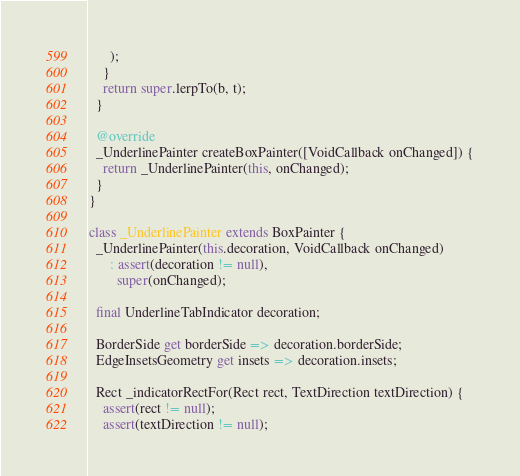Convert code to text. <code><loc_0><loc_0><loc_500><loc_500><_Dart_>      );
    }
    return super.lerpTo(b, t);
  }

  @override
  _UnderlinePainter createBoxPainter([VoidCallback onChanged]) {
    return _UnderlinePainter(this, onChanged);
  }
}

class _UnderlinePainter extends BoxPainter {
  _UnderlinePainter(this.decoration, VoidCallback onChanged)
      : assert(decoration != null),
        super(onChanged);

  final UnderlineTabIndicator decoration;

  BorderSide get borderSide => decoration.borderSide;
  EdgeInsetsGeometry get insets => decoration.insets;

  Rect _indicatorRectFor(Rect rect, TextDirection textDirection) {
    assert(rect != null);
    assert(textDirection != null);</code> 